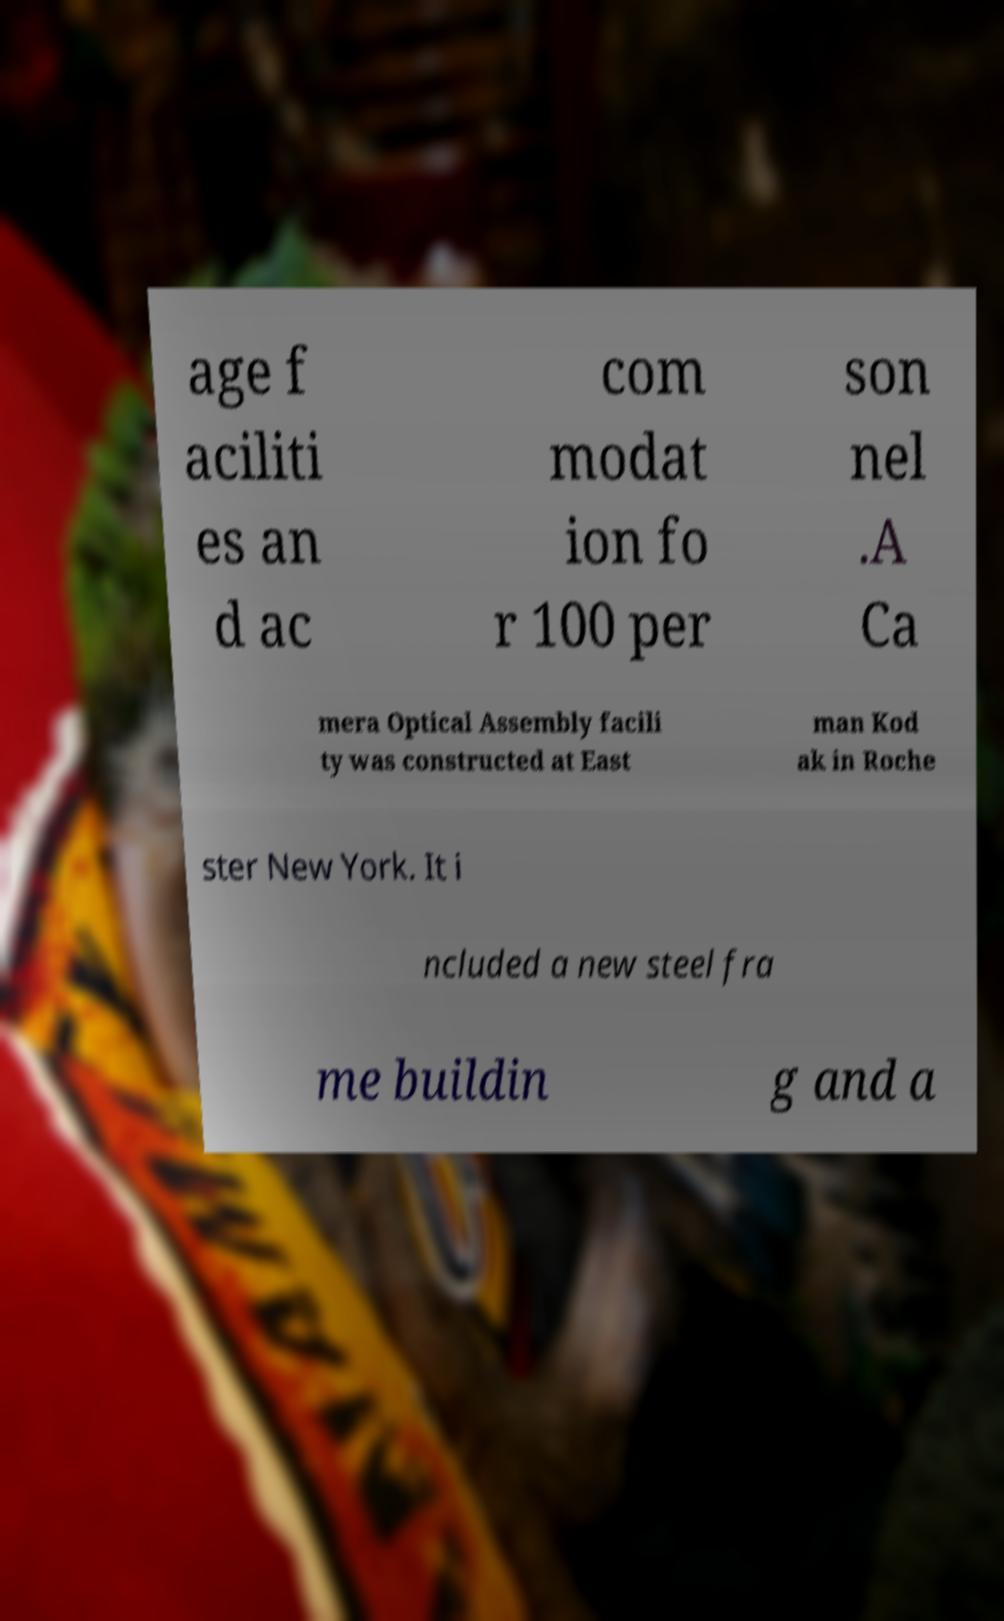Can you read and provide the text displayed in the image?This photo seems to have some interesting text. Can you extract and type it out for me? age f aciliti es an d ac com modat ion fo r 100 per son nel .A Ca mera Optical Assembly facili ty was constructed at East man Kod ak in Roche ster New York. It i ncluded a new steel fra me buildin g and a 